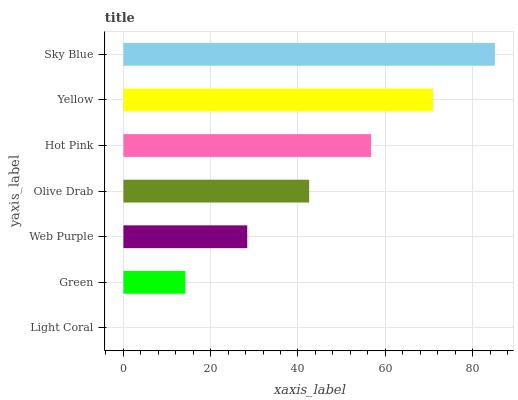Is Light Coral the minimum?
Answer yes or no. Yes. Is Sky Blue the maximum?
Answer yes or no. Yes. Is Green the minimum?
Answer yes or no. No. Is Green the maximum?
Answer yes or no. No. Is Green greater than Light Coral?
Answer yes or no. Yes. Is Light Coral less than Green?
Answer yes or no. Yes. Is Light Coral greater than Green?
Answer yes or no. No. Is Green less than Light Coral?
Answer yes or no. No. Is Olive Drab the high median?
Answer yes or no. Yes. Is Olive Drab the low median?
Answer yes or no. Yes. Is Hot Pink the high median?
Answer yes or no. No. Is Hot Pink the low median?
Answer yes or no. No. 